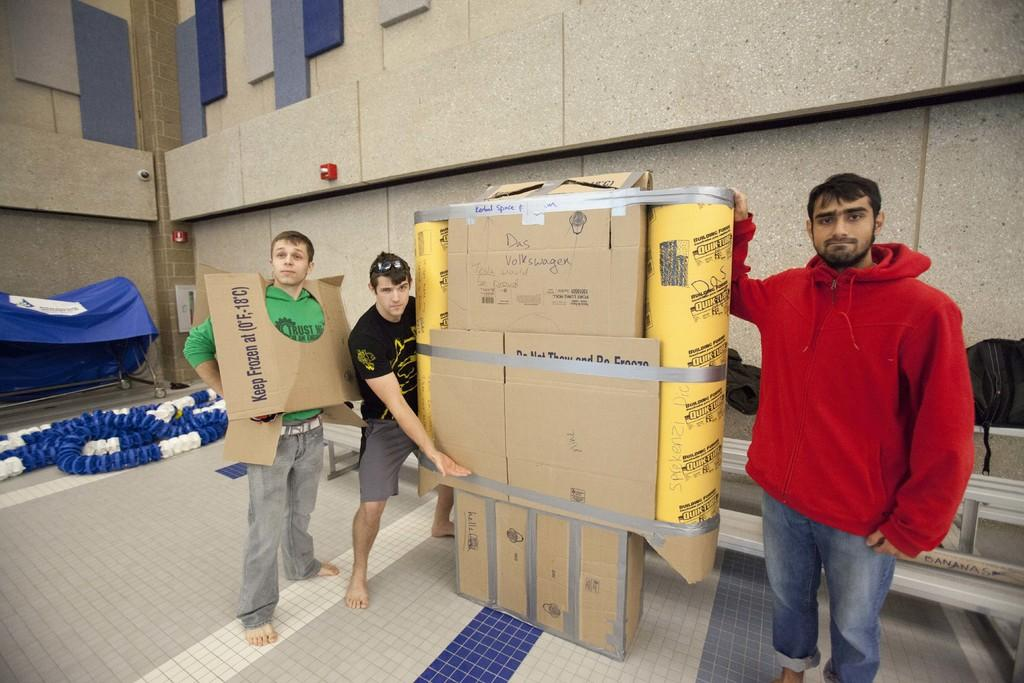Provide a one-sentence caption for the provided image. A man wearing a green shirt is wearing a piece of cardboard that says "Keep Frozen". 